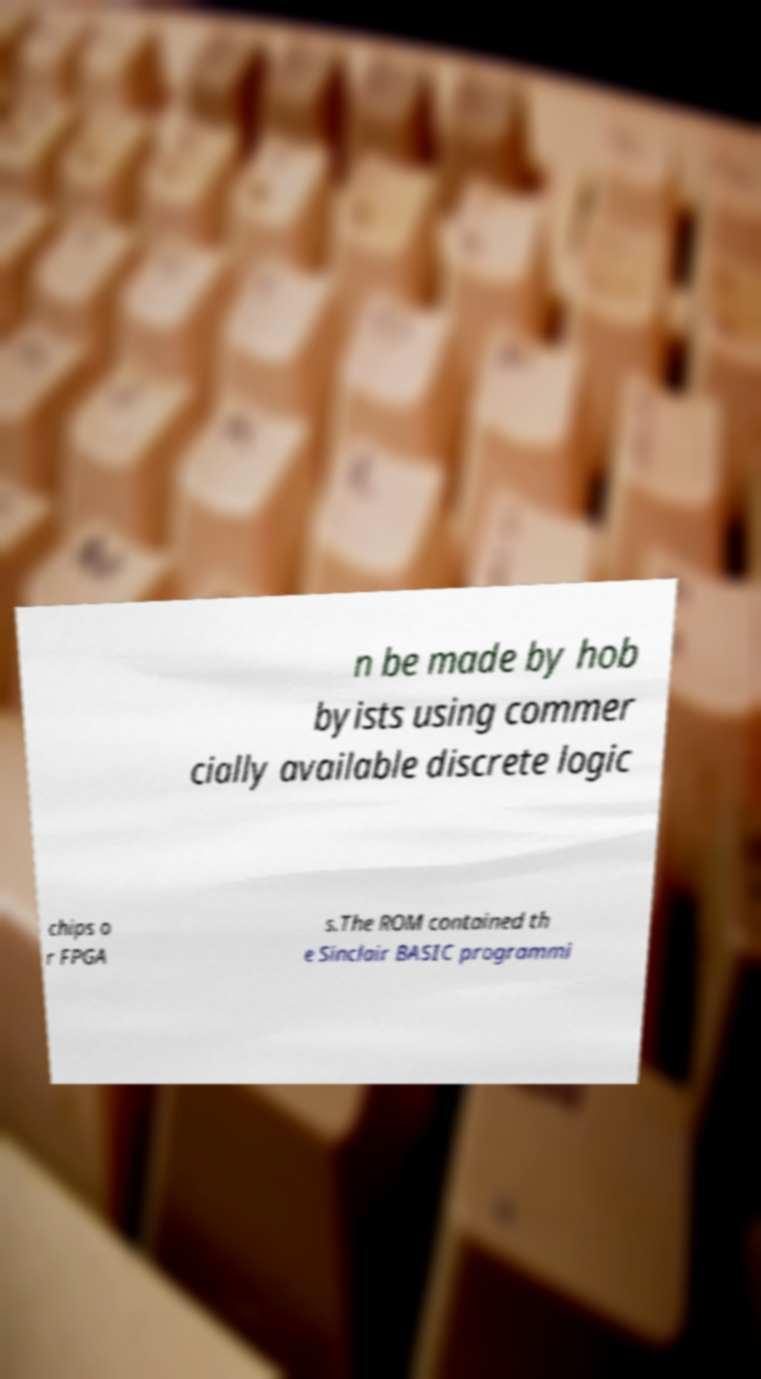There's text embedded in this image that I need extracted. Can you transcribe it verbatim? n be made by hob byists using commer cially available discrete logic chips o r FPGA s.The ROM contained th e Sinclair BASIC programmi 